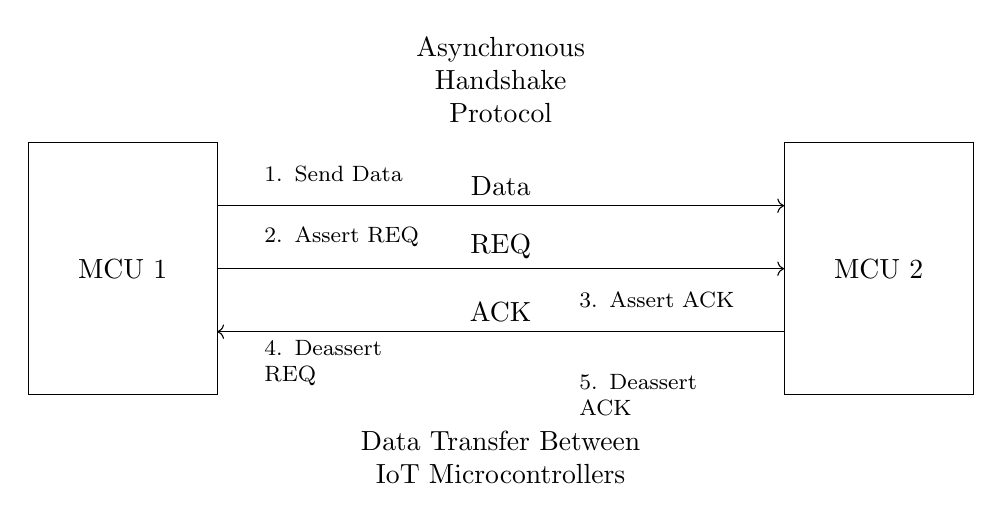What are the names of the two microcontrollers involved? The circuit diagram labels the two microcontrollers as 'MCU 1' and 'MCU 2'.
Answer: MCU 1, MCU 2 What does the arrow on the Data line indicate? The arrow on the Data line indicates the direction of data flow from MCU 1 to MCU 2.
Answer: Data flow from MCU 1 to MCU 2 How many handshake steps are indicated in the diagram? The diagram outlines a total of five handshake steps, which are numbered on the circuit.
Answer: Five What is the purpose of the REQ line in the protocol? The REQ line is used to request data transfer from MCU 1 to MCU 2, indicating that data is ready to be sent.
Answer: Request data transfer Which line is asserted first in the handshake protocol? The REQ line is asserted first according to the step sequence, immediately after sending the data.
Answer: REQ line What happens after MCU 2 receives the ACK signal? After receiving the ACK signal from MCU 2, MCU 1 deasserts the REQ line, completing the handshake process.
Answer: Deassert REQ line 